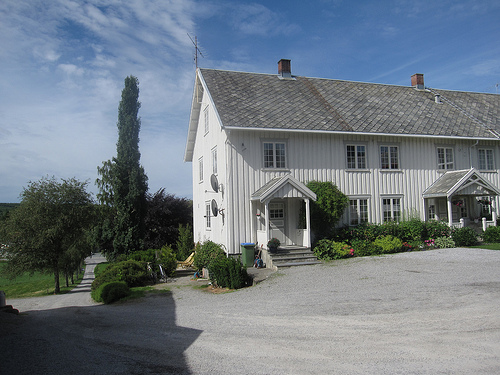<image>
Is the sky behind the building? Yes. From this viewpoint, the sky is positioned behind the building, with the building partially or fully occluding the sky. 